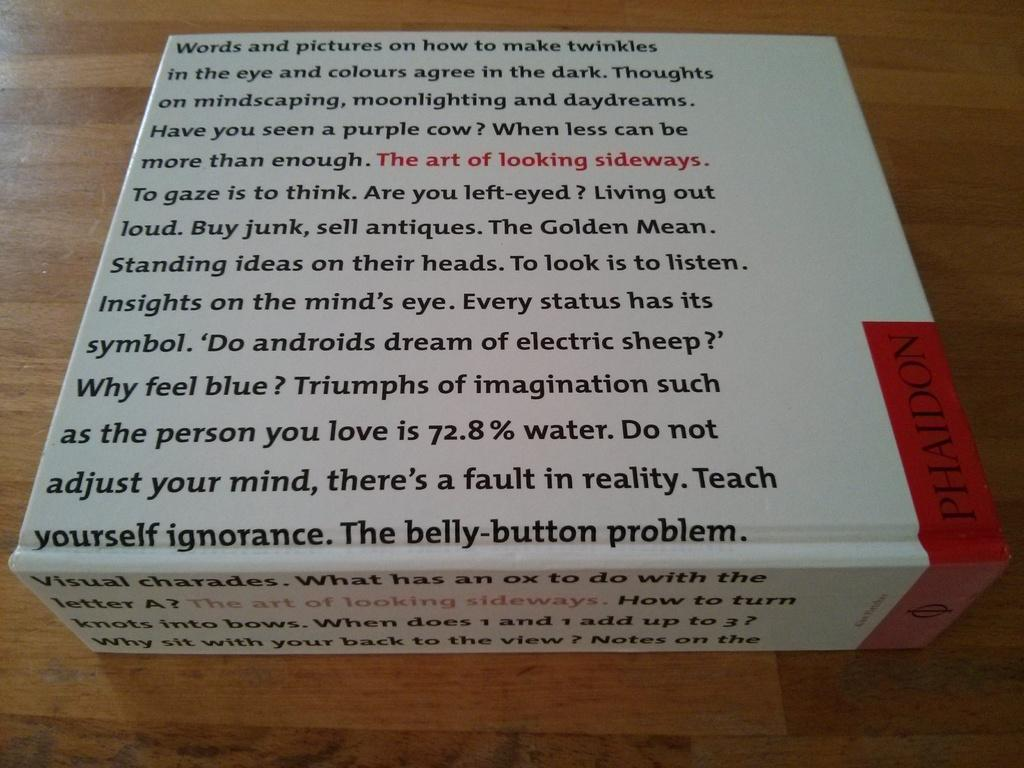Provide a one-sentence caption for the provided image. A white box covered in text including the questions "Do Androids Dream of Electric Sheep?". 